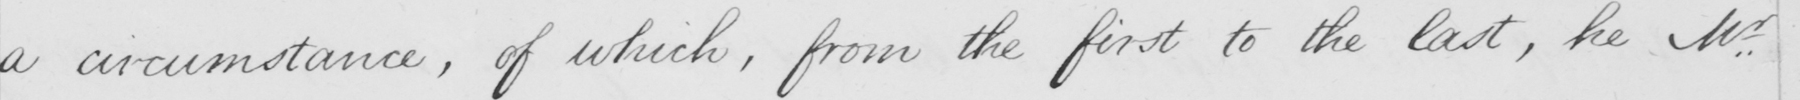Can you read and transcribe this handwriting? a circumstance , of which , from the first to the last , he Mr 